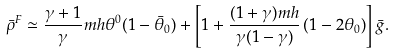<formula> <loc_0><loc_0><loc_500><loc_500>\bar { \rho } ^ { F } \simeq \frac { \gamma + 1 } { \gamma } m h \theta ^ { 0 } ( 1 - \bar { \theta } _ { 0 } ) + \left [ 1 + \frac { ( 1 + \gamma ) m h } { \gamma ( 1 - \gamma ) } \left ( 1 - 2 \theta _ { 0 } \right ) \right ] \bar { g } .</formula> 